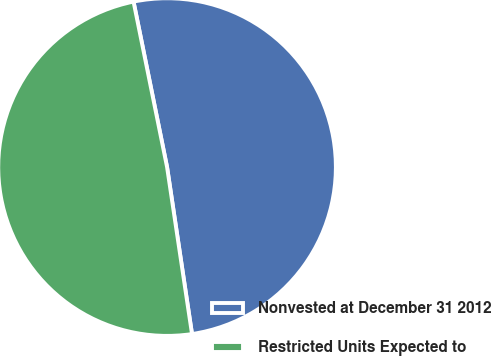Convert chart to OTSL. <chart><loc_0><loc_0><loc_500><loc_500><pie_chart><fcel>Nonvested at December 31 2012<fcel>Restricted Units Expected to<nl><fcel>50.82%<fcel>49.18%<nl></chart> 